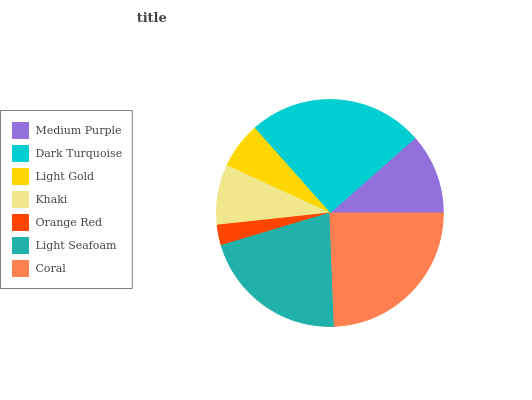Is Orange Red the minimum?
Answer yes or no. Yes. Is Dark Turquoise the maximum?
Answer yes or no. Yes. Is Light Gold the minimum?
Answer yes or no. No. Is Light Gold the maximum?
Answer yes or no. No. Is Dark Turquoise greater than Light Gold?
Answer yes or no. Yes. Is Light Gold less than Dark Turquoise?
Answer yes or no. Yes. Is Light Gold greater than Dark Turquoise?
Answer yes or no. No. Is Dark Turquoise less than Light Gold?
Answer yes or no. No. Is Medium Purple the high median?
Answer yes or no. Yes. Is Medium Purple the low median?
Answer yes or no. Yes. Is Dark Turquoise the high median?
Answer yes or no. No. Is Light Seafoam the low median?
Answer yes or no. No. 